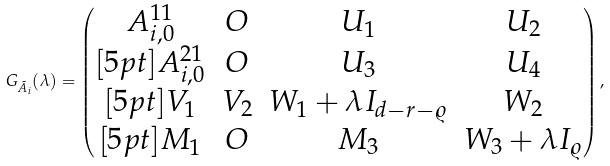<formula> <loc_0><loc_0><loc_500><loc_500>G _ { \tilde { A } _ { i } } ( \lambda ) = \left ( \begin{matrix} A _ { i , 0 } ^ { 1 1 } & O & U _ { 1 } & U _ { 2 } \\ [ 5 p t ] A _ { i , 0 } ^ { 2 1 } & O & U _ { 3 } & U _ { 4 } \\ [ 5 p t ] V _ { 1 } & V _ { 2 } & W _ { 1 } + \lambda I _ { d - r - \varrho } & W _ { 2 } \\ [ 5 p t ] M _ { 1 } & O & M _ { 3 } & W _ { 3 } + \lambda I _ { \varrho } \end{matrix} \right ) ,</formula> 